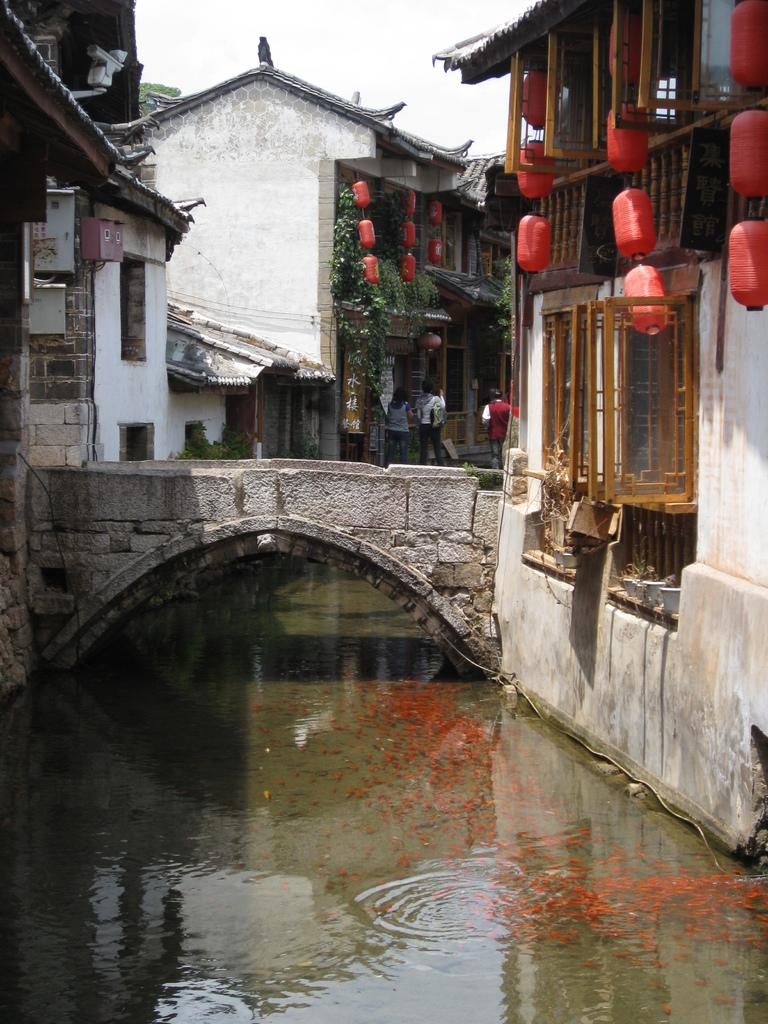What structure can be seen crossing the water in the picture? There is a bridge in the picture. What can be found in the water beneath the bridge? There are fishes in the water. What type of man-made structures are visible in the picture? There are buildings in the picture. Are there any living beings present in the picture? Yes, there are people present in the picture. What is the condition of the sky in the picture? The sky is clear in the picture. What type of vest is the grandmother wearing in the picture? There is no grandmother or vest present in the picture. Who is the partner of the person standing on the bridge in the picture? There is no partner mentioned or visible in the picture. 